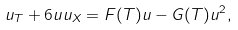<formula> <loc_0><loc_0><loc_500><loc_500>u _ { T } + 6 u u _ { X } = F ( T ) u - G ( T ) u ^ { 2 } ,</formula> 